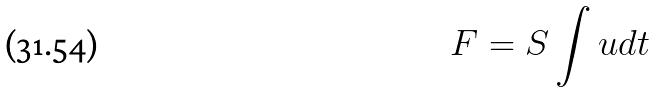<formula> <loc_0><loc_0><loc_500><loc_500>F = S \int u d t</formula> 